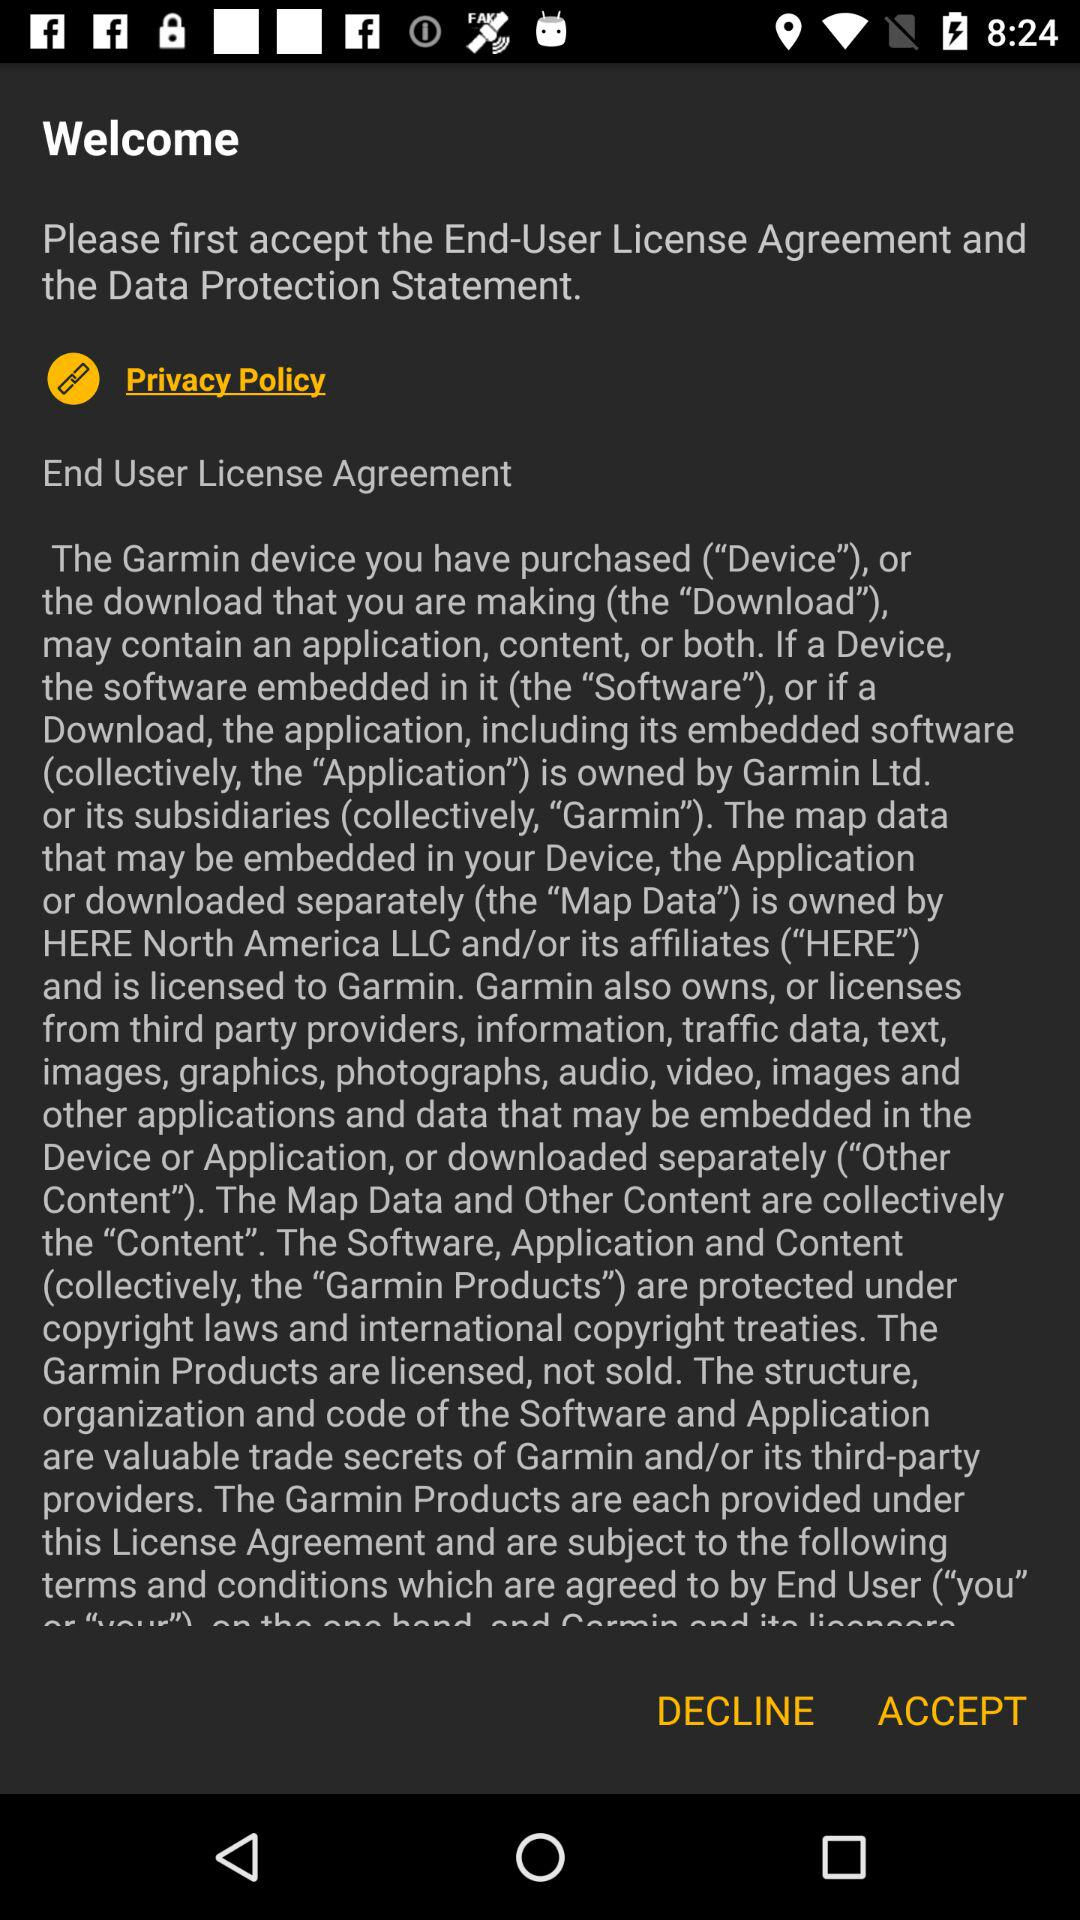What is the end user license agreement? The end user license agreement is : "The Garmin device you have purchased ("Device"), or the download that you are making (the "Download"). may contain an application, content, or both. If a Device, the software embedded in it (the "Software"), or if a Download, the application, including its embedded software (collectively, the "Application") is owned by Garmin Ltd. or its subsidiaries (collectively, "Garmin"). The map data that may be embedded in your Device, the Application or downloaded separately (the "Map Data") is owned by HERE North America LLC and/or its affiliates ("HERE") and is licensed to Garmin. Garmin also owns, or licenses from third party providers, information, traffic data, text, images, graphics, photographs, audio, video, images and other applications and data that may be embedded in the Device or Application, or downloaded separately ("Other Content"). The Map Data and Other Content are collectively the "Content". The Software, Application and Content (collectively, the "Garmin Products") are protected under copyright laws and international copyright treaties. The Garmin Products are licensed, not sold. The structure, organization and code of the Software and Application are valuable trade secrets of Garmin and/or its third-party providers. The Garmin Products are each provided under this License Agreement and are subject to the following terms and conditions which are agreed to by End User (you". 